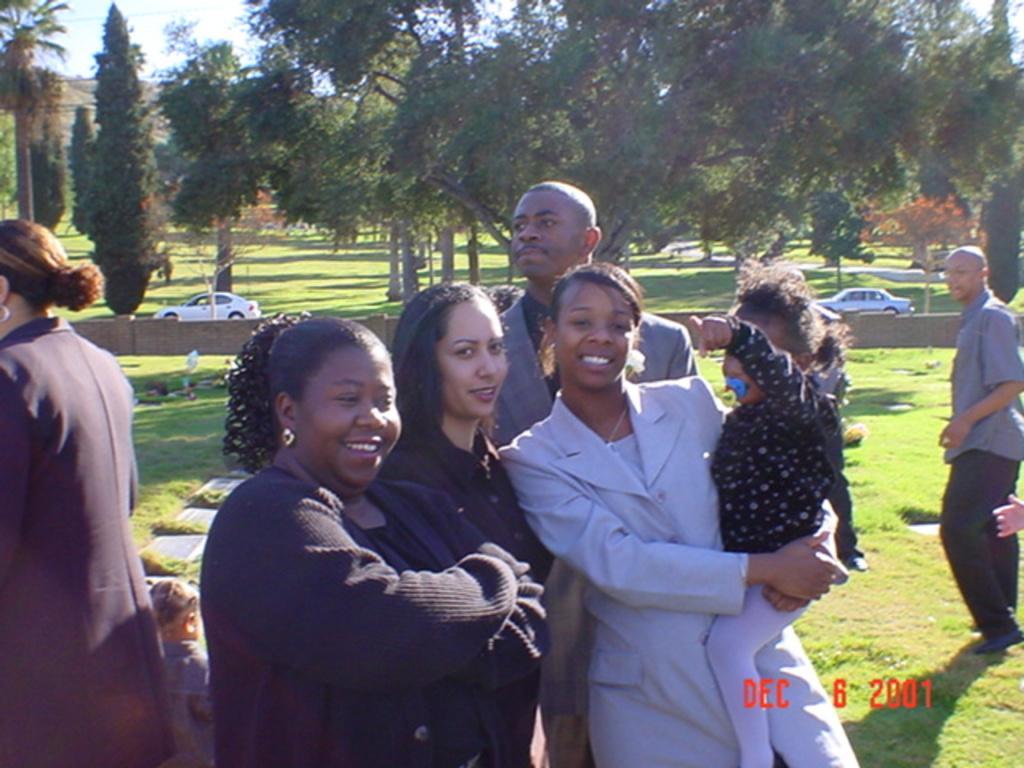In one or two sentences, can you explain what this image depicts? In this image we can see many people. There are two cars in the image. There is a grassy land in the image. There is a sky in the image. There is a road in the image. There are many trees and plants in the image. 